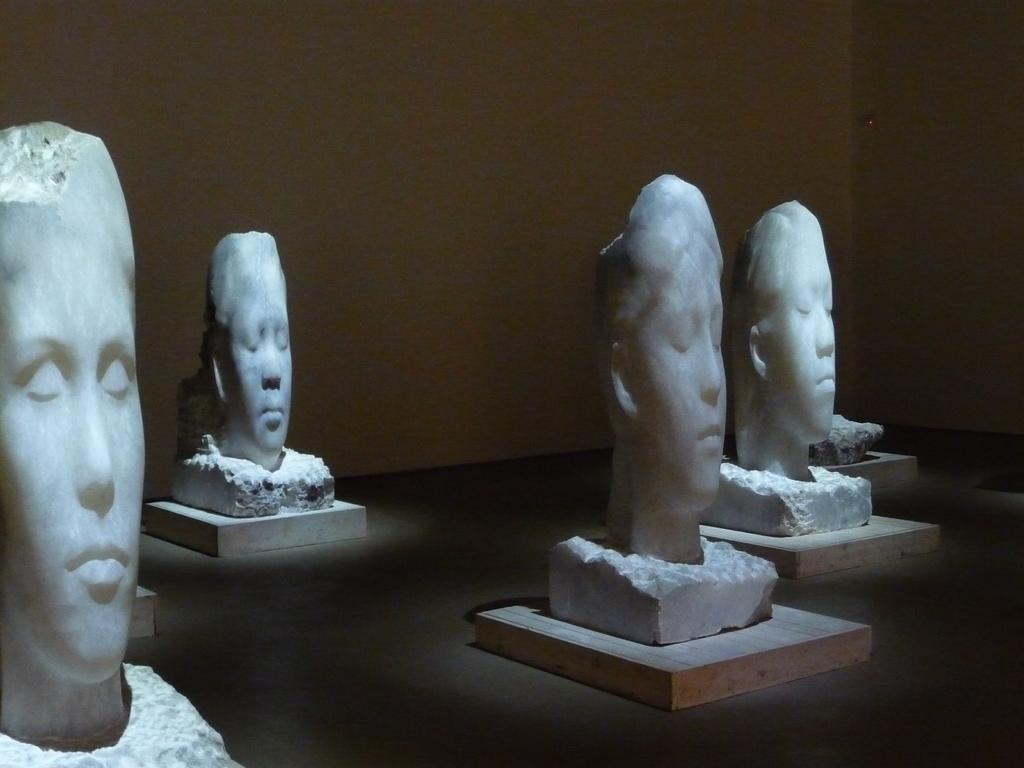Please provide a concise description of this image. In this image there are sculptures of persons faces on the wooden boards, and in the background there is wall. 